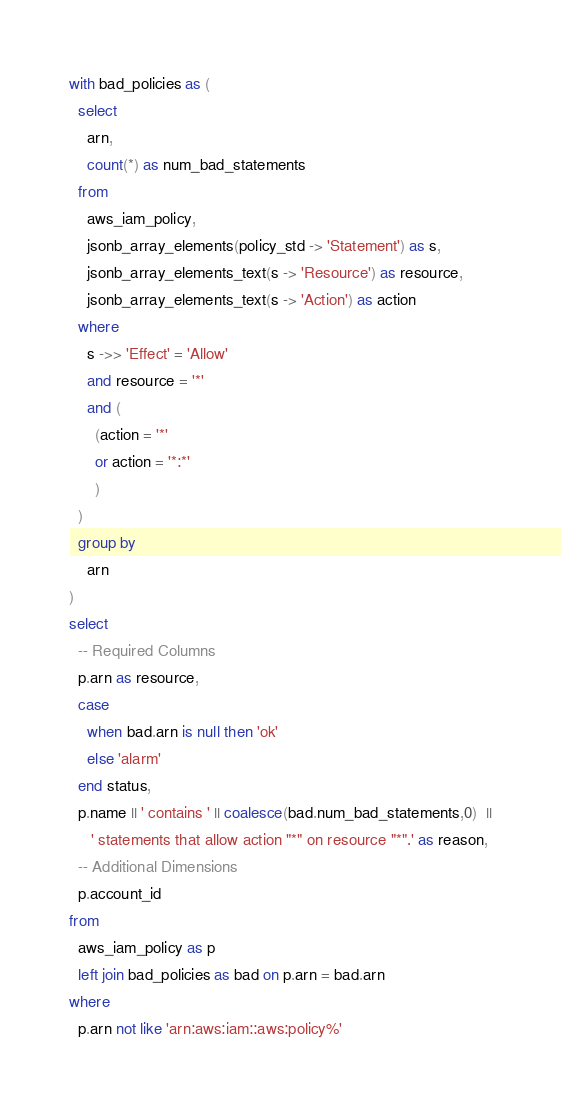<code> <loc_0><loc_0><loc_500><loc_500><_SQL_>with bad_policies as (
  select
    arn,
    count(*) as num_bad_statements
  from
    aws_iam_policy,
    jsonb_array_elements(policy_std -> 'Statement') as s,
    jsonb_array_elements_text(s -> 'Resource') as resource,
    jsonb_array_elements_text(s -> 'Action') as action
  where
    s ->> 'Effect' = 'Allow'
    and resource = '*'
    and (
      (action = '*'
      or action = '*:*'
      )
  )
  group by
    arn
)
select
  -- Required Columns
  p.arn as resource,
  case
    when bad.arn is null then 'ok'
    else 'alarm'
  end status,
  p.name || ' contains ' || coalesce(bad.num_bad_statements,0)  ||
     ' statements that allow action "*" on resource "*".' as reason,
  -- Additional Dimensions
  p.account_id
from
  aws_iam_policy as p
  left join bad_policies as bad on p.arn = bad.arn
where
  p.arn not like 'arn:aws:iam::aws:policy%'
</code> 